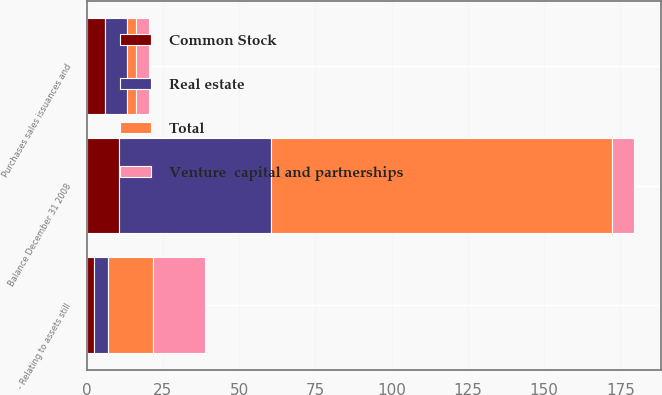Convert chart. <chart><loc_0><loc_0><loc_500><loc_500><stacked_bar_chart><ecel><fcel>Balance December 31 2008<fcel>- Relating to assets still<fcel>Purchases sales issuances and<nl><fcel>Common Stock<fcel>10.79<fcel>2.33<fcel>6<nl><fcel>Real estate<fcel>49.58<fcel>4.58<fcel>7.16<nl><fcel>Total<fcel>111.93<fcel>14.88<fcel>3.15<nl><fcel>Venture  capital and partnerships<fcel>7.16<fcel>17.13<fcel>4.31<nl></chart> 